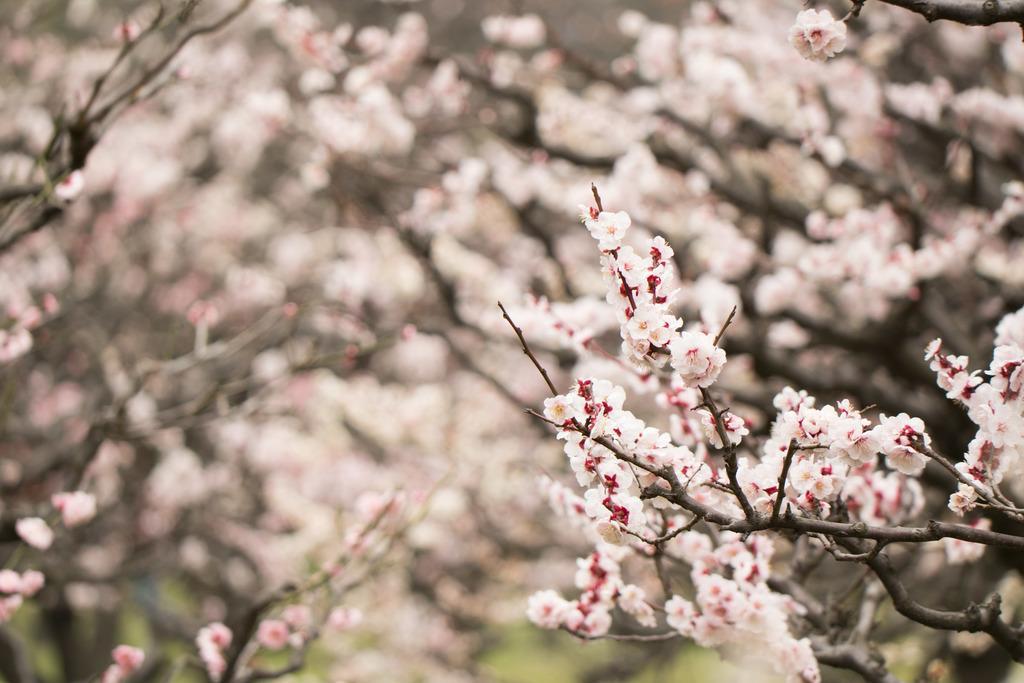In one or two sentences, can you explain what this image depicts? In this image we can see some flowers, branches and some trees, and the background is blurred. 